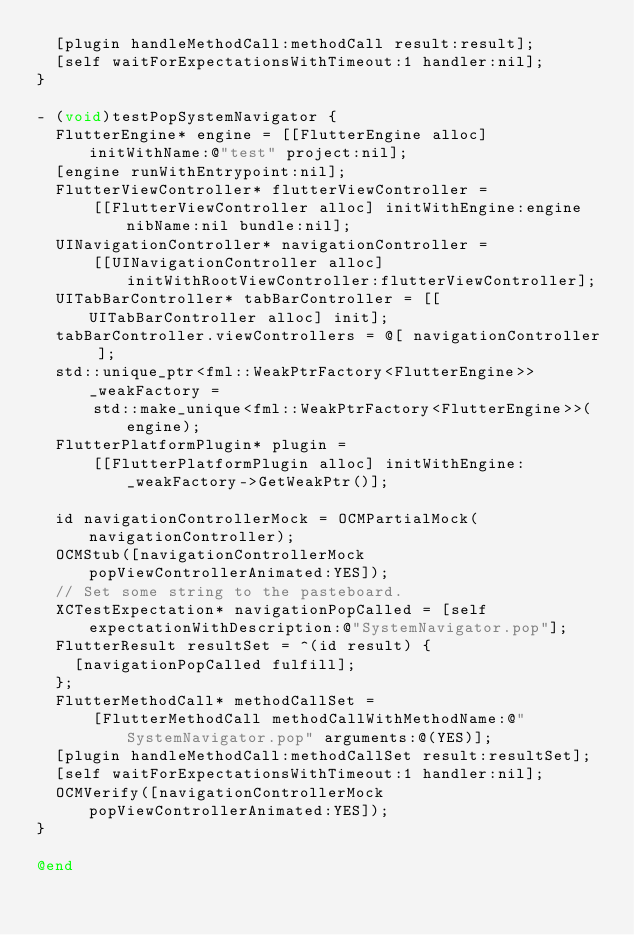<code> <loc_0><loc_0><loc_500><loc_500><_ObjectiveC_>  [plugin handleMethodCall:methodCall result:result];
  [self waitForExpectationsWithTimeout:1 handler:nil];
}

- (void)testPopSystemNavigator {
  FlutterEngine* engine = [[FlutterEngine alloc] initWithName:@"test" project:nil];
  [engine runWithEntrypoint:nil];
  FlutterViewController* flutterViewController =
      [[FlutterViewController alloc] initWithEngine:engine nibName:nil bundle:nil];
  UINavigationController* navigationController =
      [[UINavigationController alloc] initWithRootViewController:flutterViewController];
  UITabBarController* tabBarController = [[UITabBarController alloc] init];
  tabBarController.viewControllers = @[ navigationController ];
  std::unique_ptr<fml::WeakPtrFactory<FlutterEngine>> _weakFactory =
      std::make_unique<fml::WeakPtrFactory<FlutterEngine>>(engine);
  FlutterPlatformPlugin* plugin =
      [[FlutterPlatformPlugin alloc] initWithEngine:_weakFactory->GetWeakPtr()];

  id navigationControllerMock = OCMPartialMock(navigationController);
  OCMStub([navigationControllerMock popViewControllerAnimated:YES]);
  // Set some string to the pasteboard.
  XCTestExpectation* navigationPopCalled = [self expectationWithDescription:@"SystemNavigator.pop"];
  FlutterResult resultSet = ^(id result) {
    [navigationPopCalled fulfill];
  };
  FlutterMethodCall* methodCallSet =
      [FlutterMethodCall methodCallWithMethodName:@"SystemNavigator.pop" arguments:@(YES)];
  [plugin handleMethodCall:methodCallSet result:resultSet];
  [self waitForExpectationsWithTimeout:1 handler:nil];
  OCMVerify([navigationControllerMock popViewControllerAnimated:YES]);
}

@end
</code> 